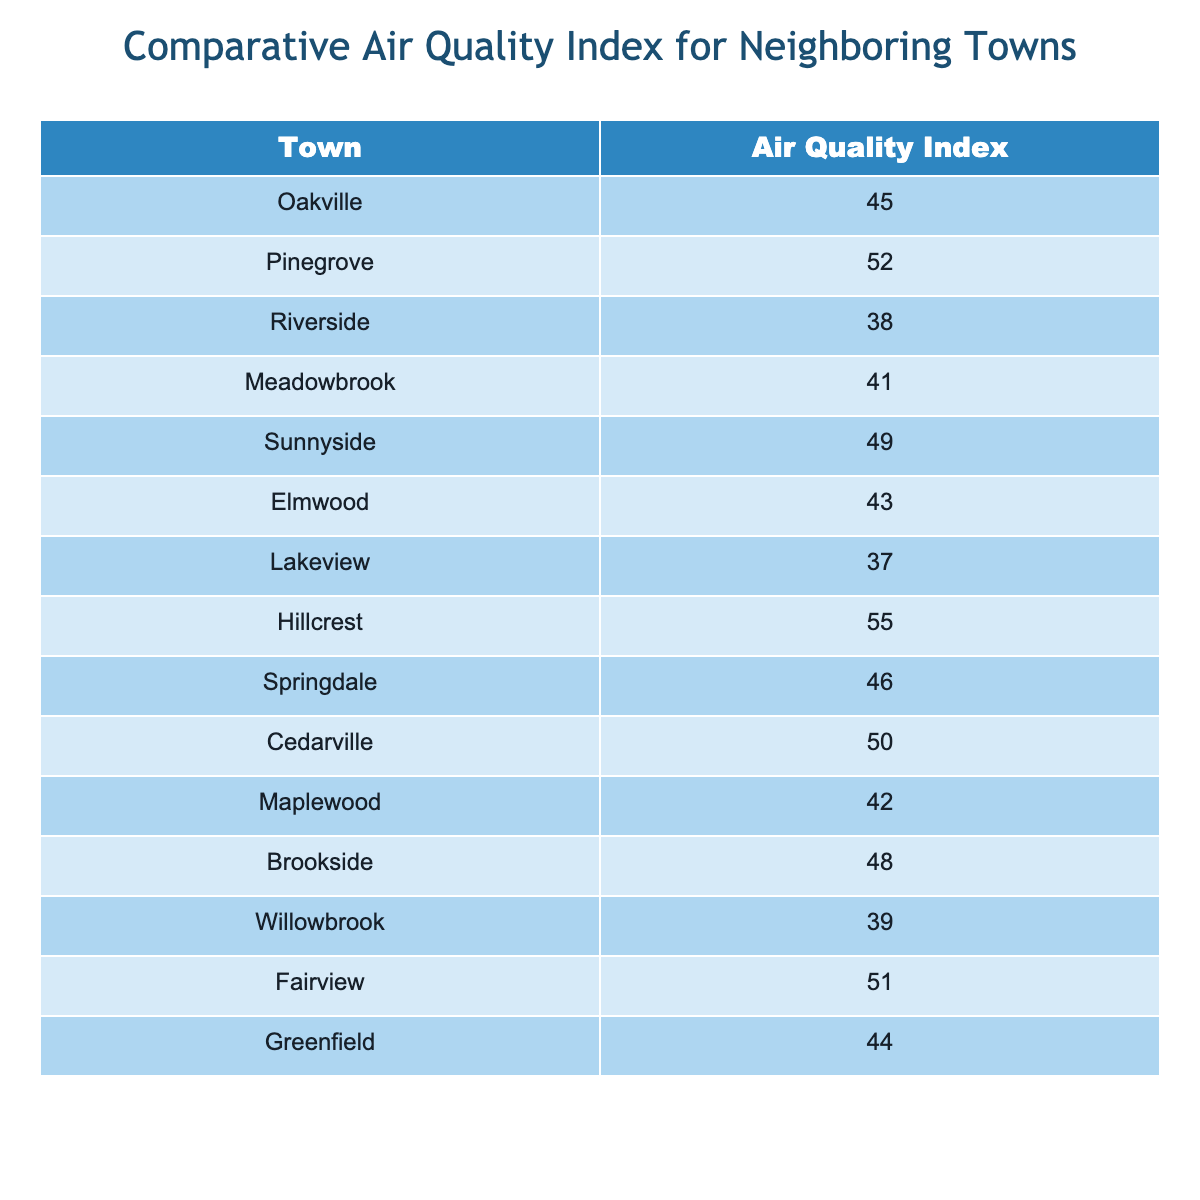What is the Air Quality Index of Riverside? The table lists the Air Quality Index for each town, and Riverside is explicitly noted with a value of 38.
Answer: 38 Which town has the highest Air Quality Index? By comparing the values in the table, Hillcrest has the highest Air Quality Index at 55.
Answer: Hillcrest What is the difference in Air Quality Index between Oakville and Lakeview? Oakville has an index of 45 and Lakeview has 37. The difference is calculated as 45 - 37, which equals 8.
Answer: 8 What town has an Air Quality Index of 41? Meadowbrook is named in the table with an Air Quality Index of 41, explicitly indicating this value.
Answer: Meadowbrook What is the average Air Quality Index of all towns listed? To find the average, sum up all the indices: (45 + 52 + 38 + 41 + 49 + 43 + 37 + 55 + 46 + 50 + 42 + 48 + 39 + 51 + 44) = 673. Then divide by 15 (the number of towns) which results in 673/15 = 44.87.
Answer: 44.87 Is the Air Quality Index of Sunnyside higher than that of Elmwood? Summarizing the values, Sunnyside has an index of 49, while Elmwood's index is 43. Since 49 is greater than 43, the statement is true.
Answer: Yes Which two towns have Air Quality Indices closest to each other? By scanning the table, Elmwood (43) and Lakeview (37) have the smallest difference of 6. Therefore, they are the closest.
Answer: Elmwood and Lakeview What is the combined Air Quality Index of Cedarville and Fairview? Cedarville has an index of 50 and Fairview has 51. Their combined index is 50 + 51 = 101.
Answer: 101 Which towns have an Air Quality Index below 40? Referring to the table, the towns with indices below 40 are Riverside (38) and Lakeview (37).
Answer: Riverside and Lakeview How many towns have an Air Quality Index above 45? The towns with indices above 45 are Pinegrove (52), Sunnyside (49), Hillcrest (55), Springdale (46), Cedarville (50), and Fairview (51). Counting these gives a total of 6 towns.
Answer: 6 